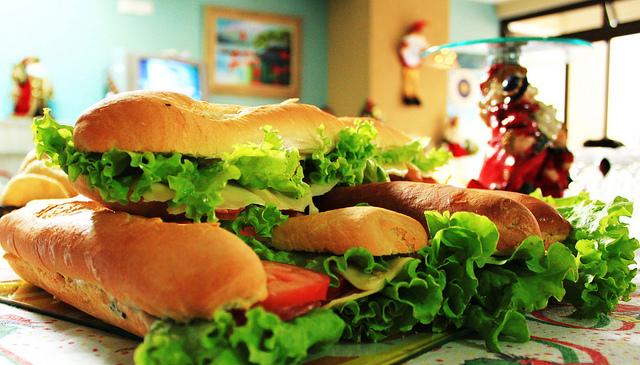What are green?
Write a very short answer. Lettuce. What is on top the lettuce?
Be succinct. Bread. Is this a sandwich?
Give a very brief answer. Yes. Is there a lot of lettuce on these sandwiches?
Answer briefly. Yes. 